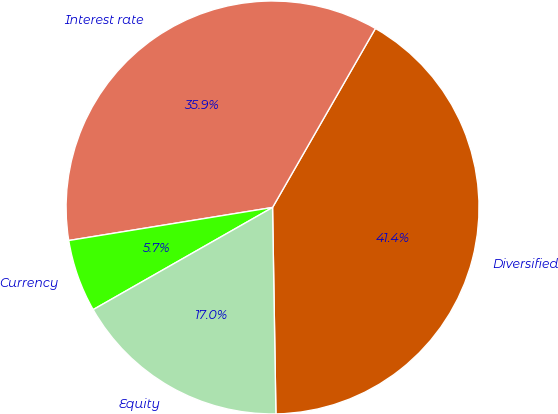Convert chart. <chart><loc_0><loc_0><loc_500><loc_500><pie_chart><fcel>Diversified<fcel>Interest rate<fcel>Currency<fcel>Equity<nl><fcel>41.44%<fcel>35.86%<fcel>5.68%<fcel>17.02%<nl></chart> 